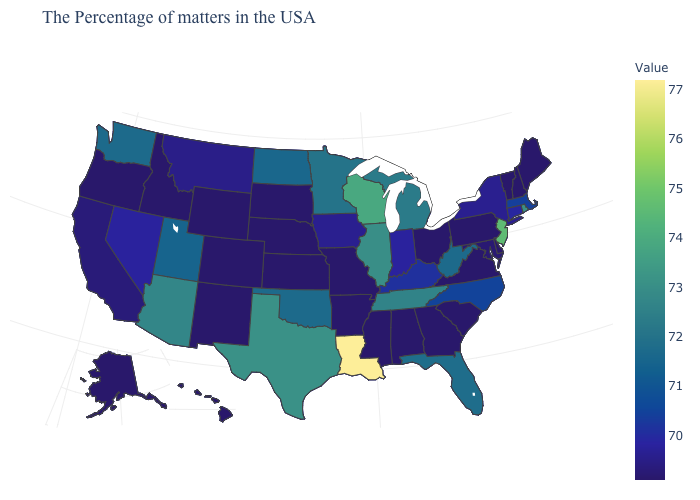Is the legend a continuous bar?
Be succinct. Yes. Does Ohio have the lowest value in the MidWest?
Quick response, please. Yes. Does California have the highest value in the West?
Write a very short answer. No. 